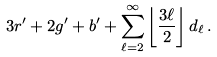<formula> <loc_0><loc_0><loc_500><loc_500>3 r ^ { \prime } + 2 g ^ { \prime } + b ^ { \prime } + \sum _ { \ell = 2 } ^ { \infty } \left \lfloor \frac { 3 \ell } { 2 } \right \rfloor d _ { \ell } \, .</formula> 